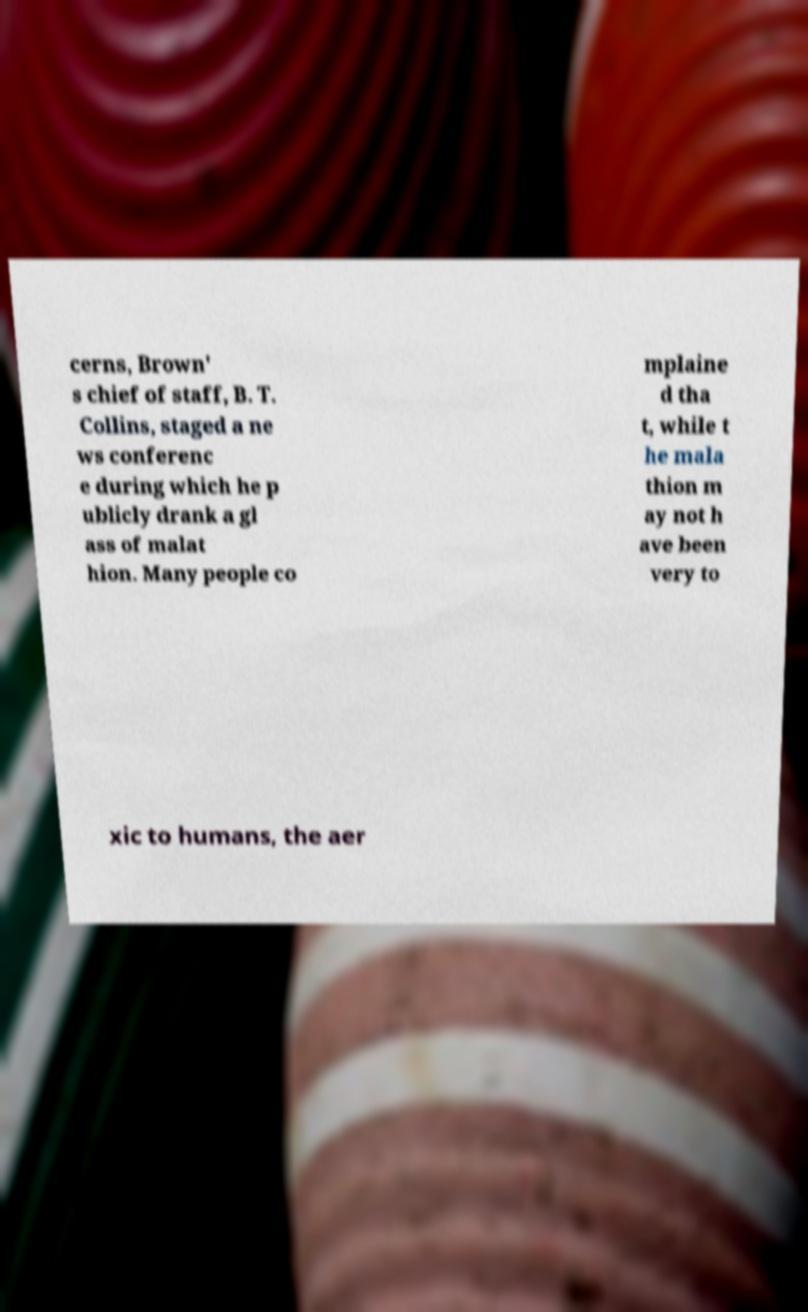Can you accurately transcribe the text from the provided image for me? cerns, Brown' s chief of staff, B. T. Collins, staged a ne ws conferenc e during which he p ublicly drank a gl ass of malat hion. Many people co mplaine d tha t, while t he mala thion m ay not h ave been very to xic to humans, the aer 